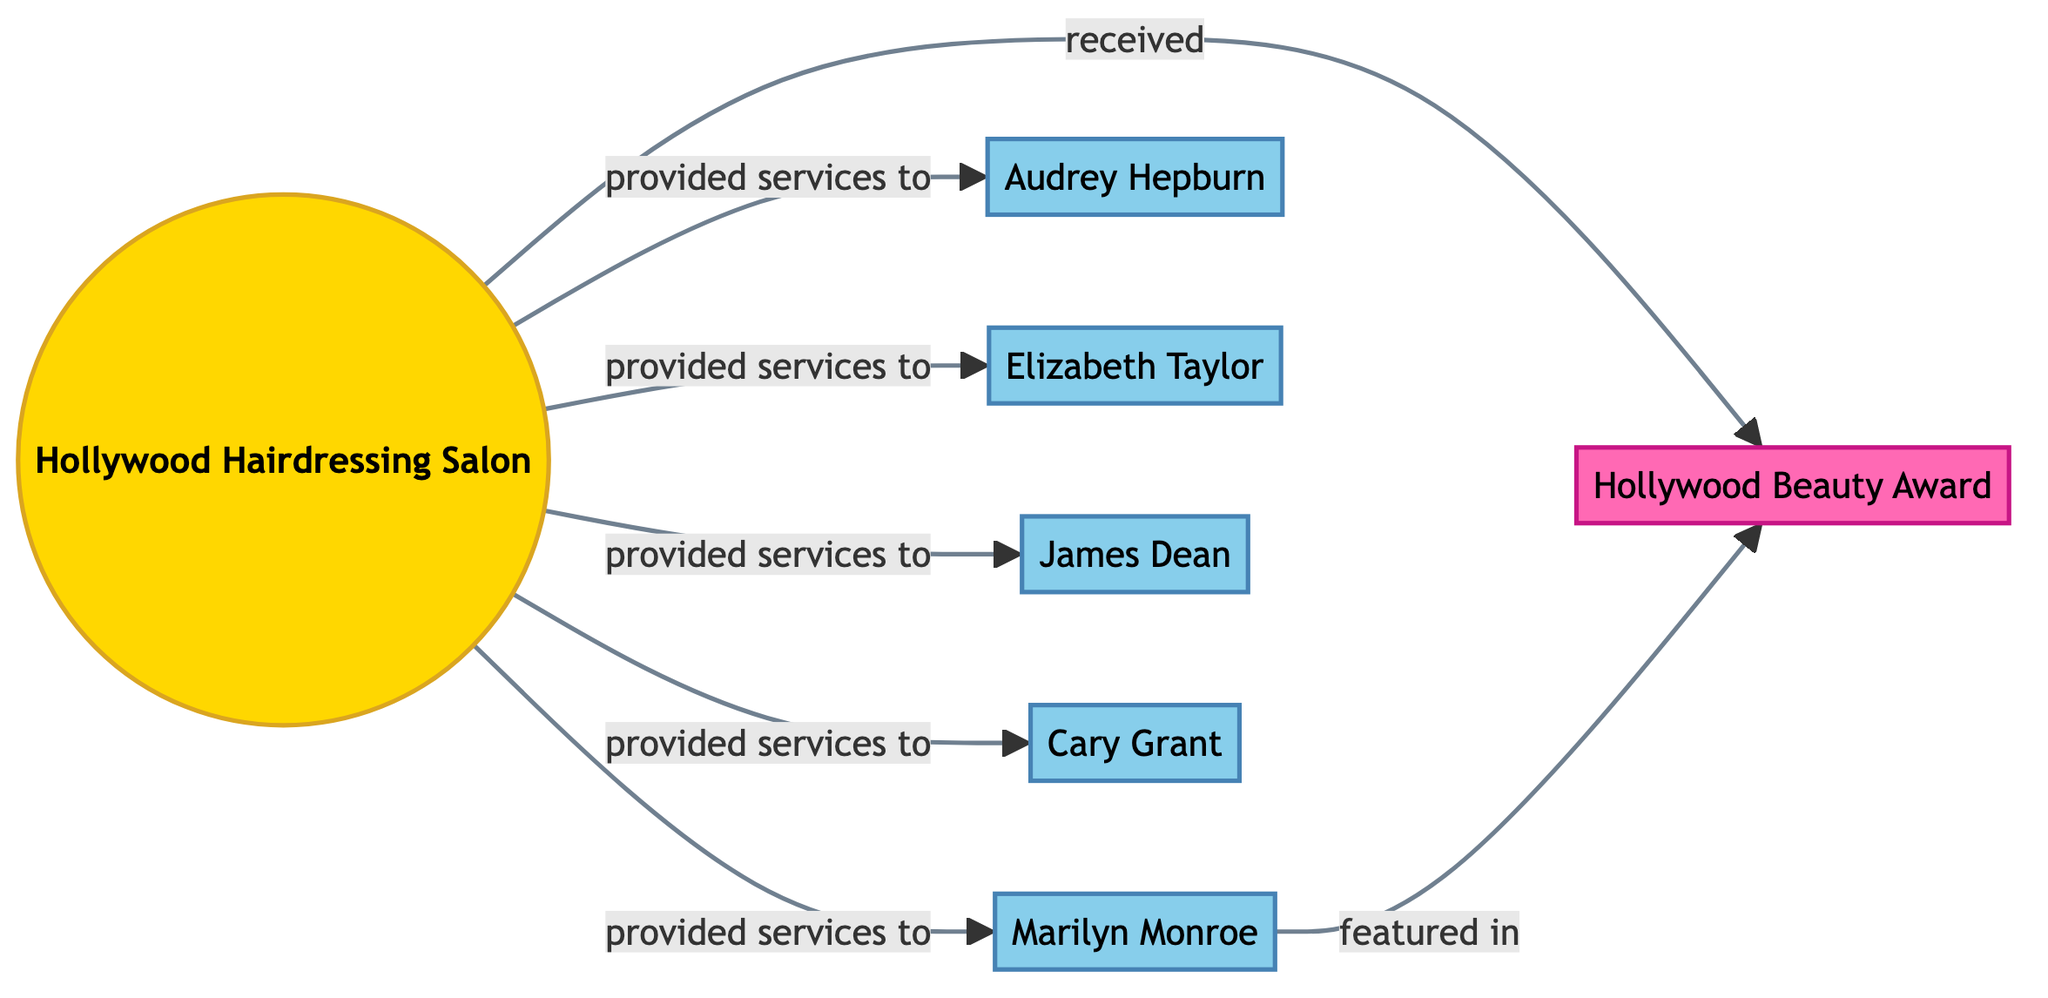How many clients are represented in the diagram? The diagram shows nodes that are identified as clients. There are five distinct client nodes: Marilyn Monroe, Audrey Hepburn, Elizabeth Taylor, James Dean, and Cary Grant. Therefore, the total number of clients is five.
Answer: 5 Which event is connected to the Hollywood Hairdressing Salon? The diagram connects the Hollywood Hairdressing Salon to the Hollywood Beauty Award. This is indicated by an edge labeled "received," showing that the salon received the award.
Answer: Hollywood Beauty Award What is the relationship between Marilyn Monroe and the Hollywood Hairdressing Salon? The diagram shows an edge from the Hollywood Hairdressing Salon to Marilyn Monroe labeled "provided hairdressing services to". This indicates the service relationship between them.
Answer: provided hairdressing services to Who is featured in the Hollywood Beauty Award? From the diagram, there is an edge from Marilyn Monroe to the Hollywood Beauty Award labeled "featured in". Therefore, Marilyn Monroe is the person featured in the award.
Answer: Marilyn Monroe How many connections does the salon have? The salon has edges to five clients and one event, totaling six connections. This can be counted directly from the outgoing relationships from the salon node.
Answer: 6 Which client has a direct connection to the Hollywood Beauty Award? The only client with a direct connection to the Hollywood Beauty Award is Marilyn Monroe, indicated by the edge labeled "featured in." Thus, she is the client linked to the award.
Answer: Marilyn Monroe What type of nodes are represented in the diagram? The diagram includes three types of nodes: an entity (Hollywood Hairdressing Salon), clients (e.g., Marilyn Monroe), and an event (Hollywood Beauty Award). This categorization can be identified through the defined node types.
Answer: entity, client, event How many edges are connected to the client Cary Grant? The diagram shows an edge from the salon to Cary Grant, indicating that he was provided hairdressing services. There are no other edges connected to Cary Grant, so the count is one.
Answer: 1 